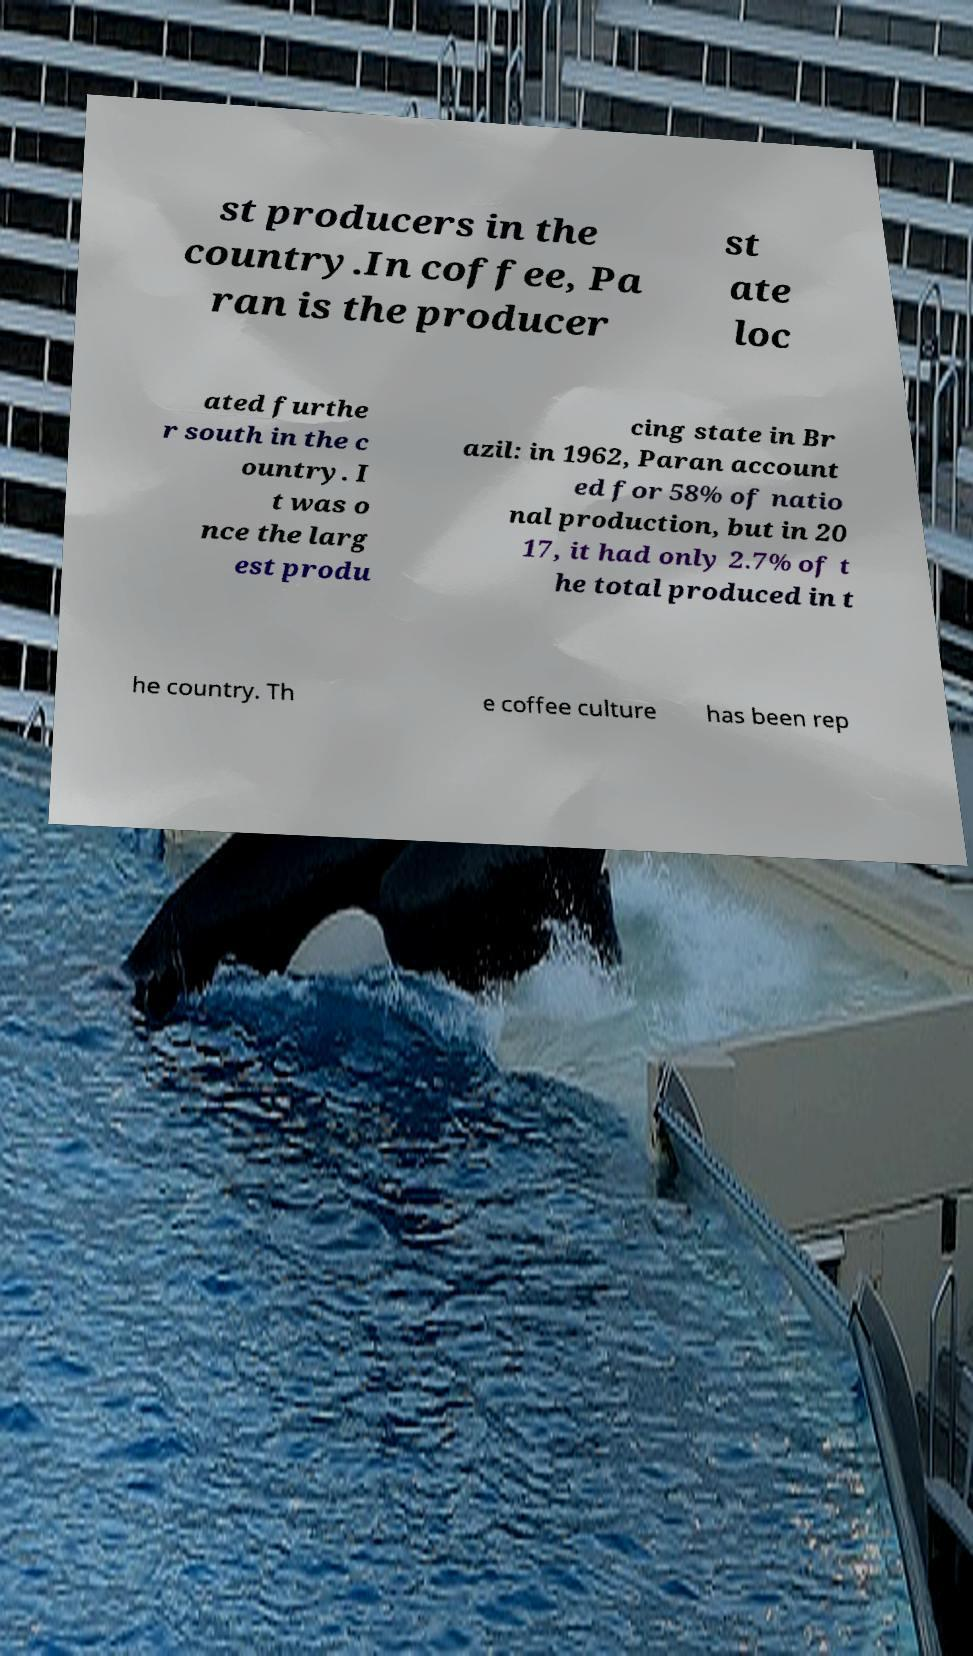Could you assist in decoding the text presented in this image and type it out clearly? st producers in the country.In coffee, Pa ran is the producer st ate loc ated furthe r south in the c ountry. I t was o nce the larg est produ cing state in Br azil: in 1962, Paran account ed for 58% of natio nal production, but in 20 17, it had only 2.7% of t he total produced in t he country. Th e coffee culture has been rep 